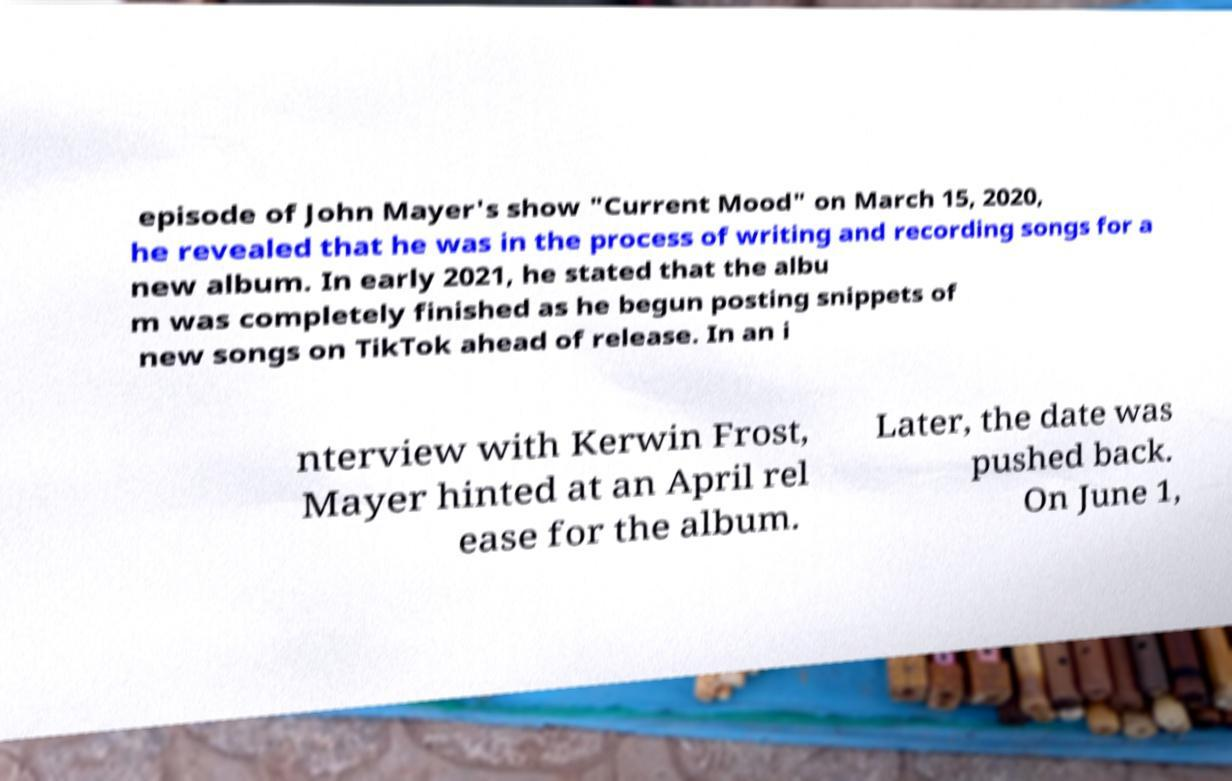Could you assist in decoding the text presented in this image and type it out clearly? episode of John Mayer's show "Current Mood" on March 15, 2020, he revealed that he was in the process of writing and recording songs for a new album. In early 2021, he stated that the albu m was completely finished as he begun posting snippets of new songs on TikTok ahead of release. In an i nterview with Kerwin Frost, Mayer hinted at an April rel ease for the album. Later, the date was pushed back. On June 1, 